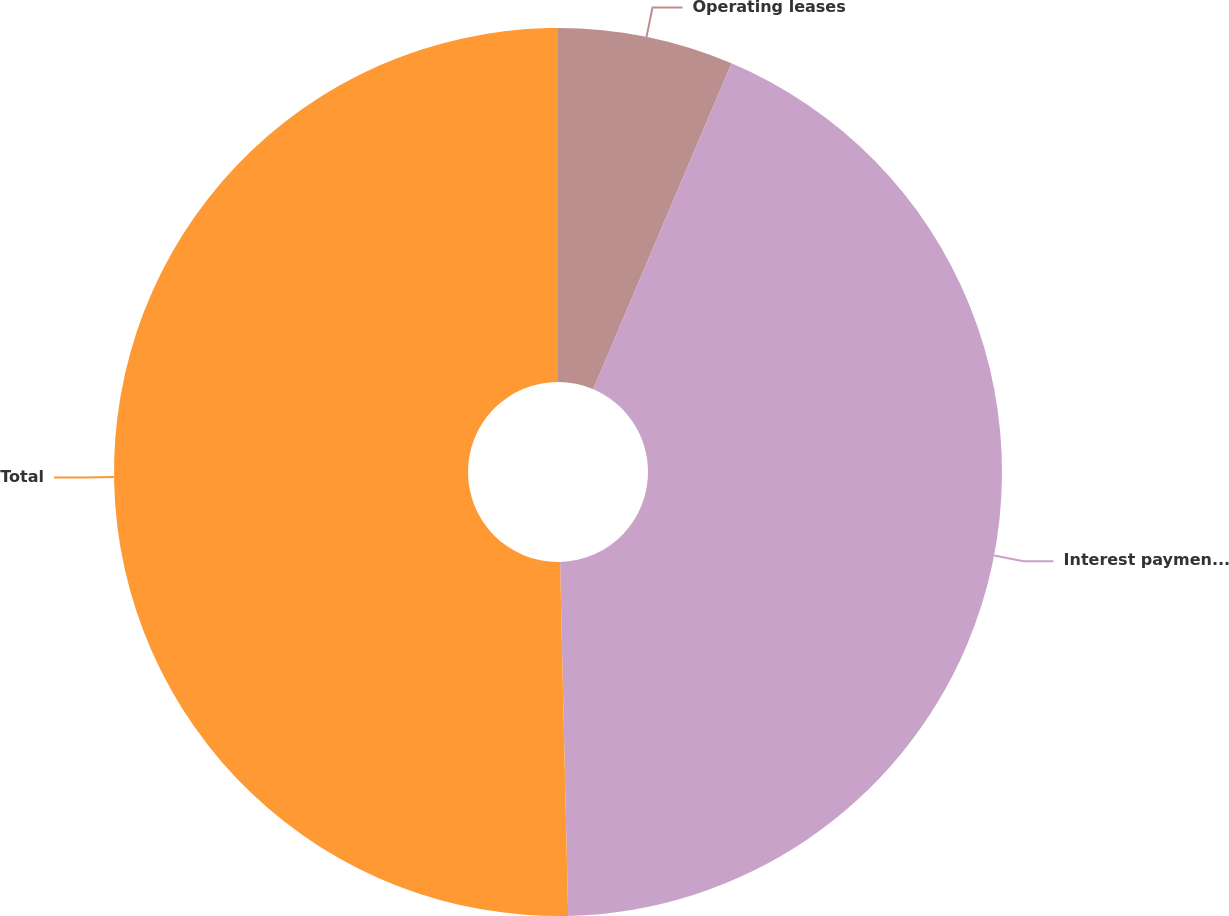<chart> <loc_0><loc_0><loc_500><loc_500><pie_chart><fcel>Operating leases<fcel>Interest payments on long-term<fcel>Total<nl><fcel>6.39%<fcel>43.25%<fcel>50.37%<nl></chart> 